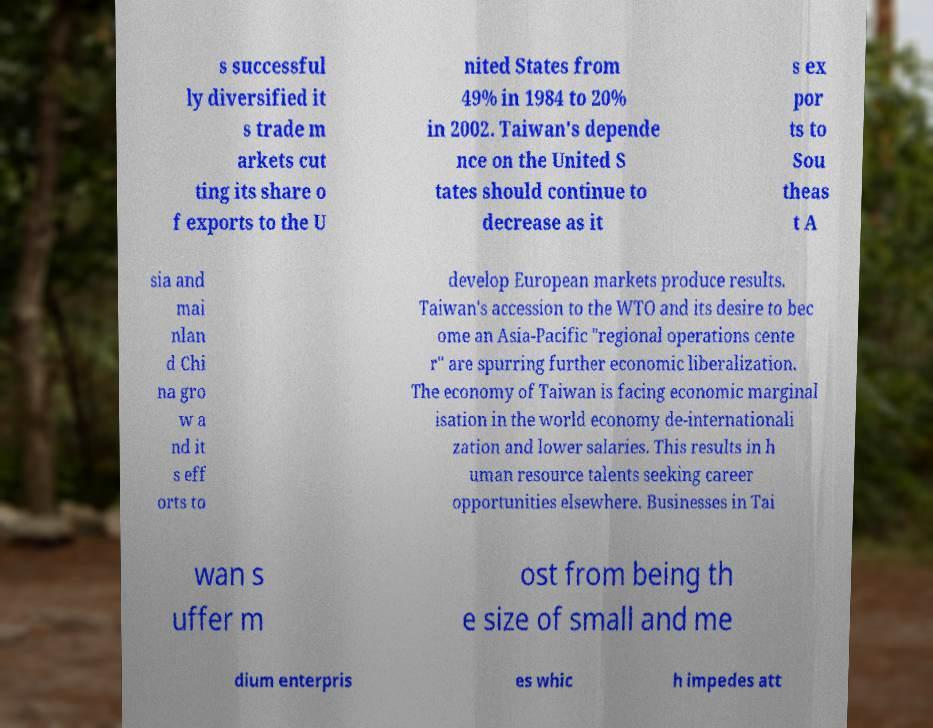I need the written content from this picture converted into text. Can you do that? s successful ly diversified it s trade m arkets cut ting its share o f exports to the U nited States from 49% in 1984 to 20% in 2002. Taiwan's depende nce on the United S tates should continue to decrease as it s ex por ts to Sou theas t A sia and mai nlan d Chi na gro w a nd it s eff orts to develop European markets produce results. Taiwan's accession to the WTO and its desire to bec ome an Asia-Pacific "regional operations cente r" are spurring further economic liberalization. The economy of Taiwan is facing economic marginal isation in the world economy de-internationali zation and lower salaries. This results in h uman resource talents seeking career opportunities elsewhere. Businesses in Tai wan s uffer m ost from being th e size of small and me dium enterpris es whic h impedes att 